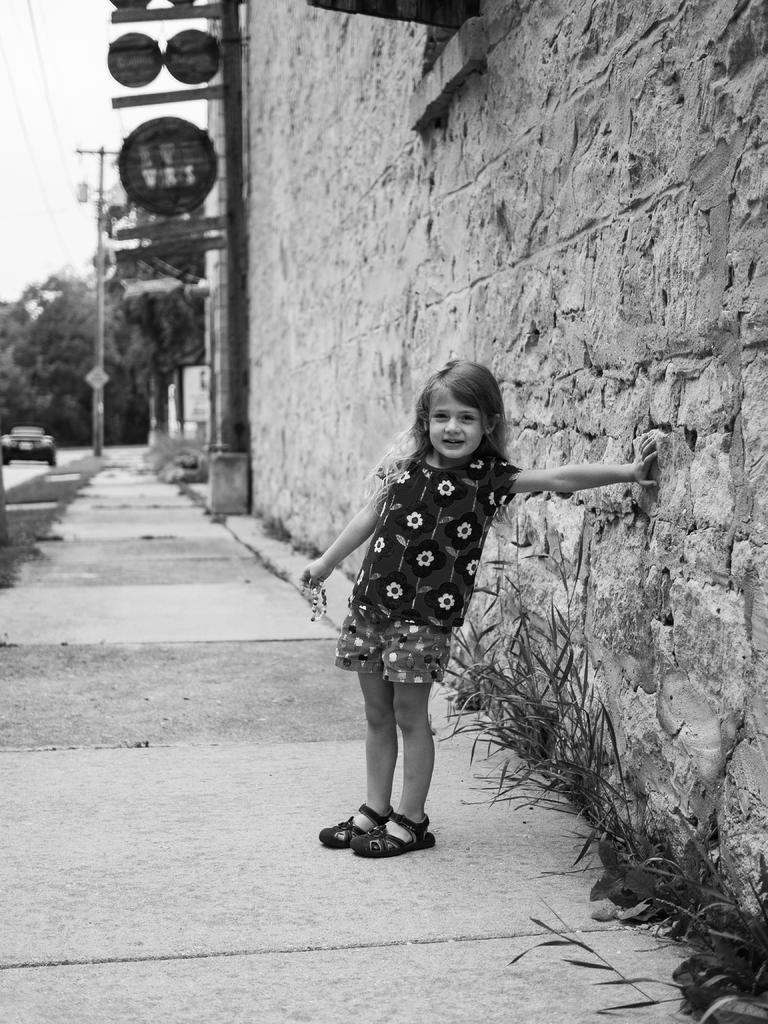What is the child in the image doing? The child is standing and touching the wall in the image. What structure can be seen in the image? There are boards attached to a pole in the image. What is on the ground in the image? There is a vehicle on the ground in the image. What can be seen in the background of the image? The sky is visible in the background of the image. Are the child's sisters attending the church service in the image? There is no church or sisters present in the image. What kind of trouble is the child causing in the image? There is no indication of trouble in the image; the child is simply standing and touching the wall. 